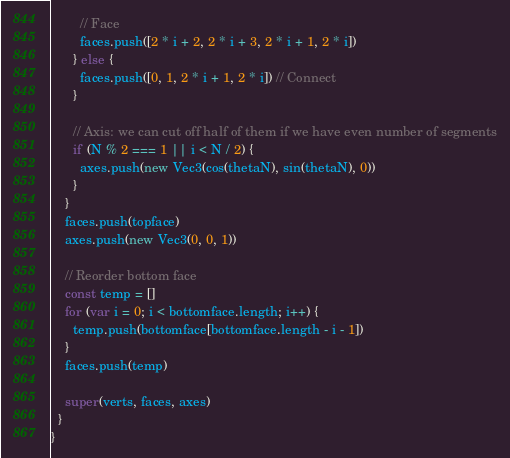<code> <loc_0><loc_0><loc_500><loc_500><_JavaScript_>
        // Face
        faces.push([2 * i + 2, 2 * i + 3, 2 * i + 1, 2 * i])
      } else {
        faces.push([0, 1, 2 * i + 1, 2 * i]) // Connect
      }

      // Axis: we can cut off half of them if we have even number of segments
      if (N % 2 === 1 || i < N / 2) {
        axes.push(new Vec3(cos(thetaN), sin(thetaN), 0))
      }
    }
    faces.push(topface)
    axes.push(new Vec3(0, 0, 1))

    // Reorder bottom face
    const temp = []
    for (var i = 0; i < bottomface.length; i++) {
      temp.push(bottomface[bottomface.length - i - 1])
    }
    faces.push(temp)

    super(verts, faces, axes)
  }
}
</code> 